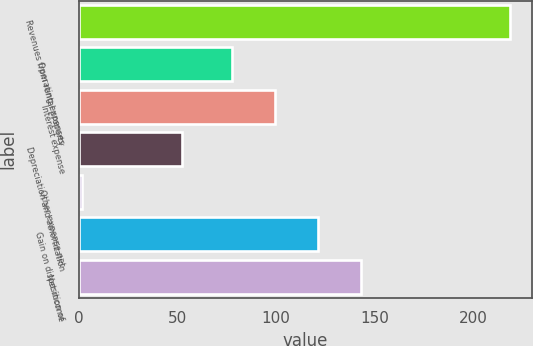<chart> <loc_0><loc_0><loc_500><loc_500><bar_chart><fcel>Revenues from rental property<fcel>Operating expenses<fcel>Interest expense<fcel>Depreciation and amortization<fcel>Other expense net<fcel>Gain on disposition of<fcel>Net income<nl><fcel>218.7<fcel>77.9<fcel>99.61<fcel>52.1<fcel>1.6<fcel>121.32<fcel>143.03<nl></chart> 